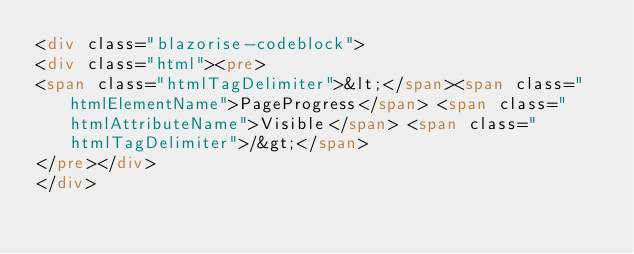Convert code to text. <code><loc_0><loc_0><loc_500><loc_500><_HTML_><div class="blazorise-codeblock">
<div class="html"><pre>
<span class="htmlTagDelimiter">&lt;</span><span class="htmlElementName">PageProgress</span> <span class="htmlAttributeName">Visible</span> <span class="htmlTagDelimiter">/&gt;</span>
</pre></div>
</div>
</code> 